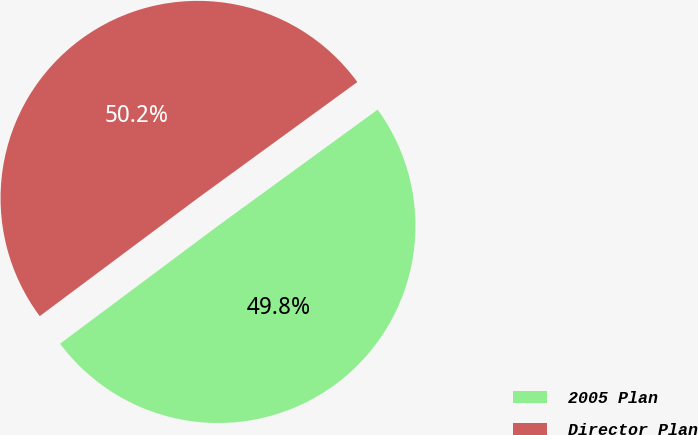<chart> <loc_0><loc_0><loc_500><loc_500><pie_chart><fcel>2005 Plan<fcel>Director Plan<nl><fcel>49.81%<fcel>50.19%<nl></chart> 